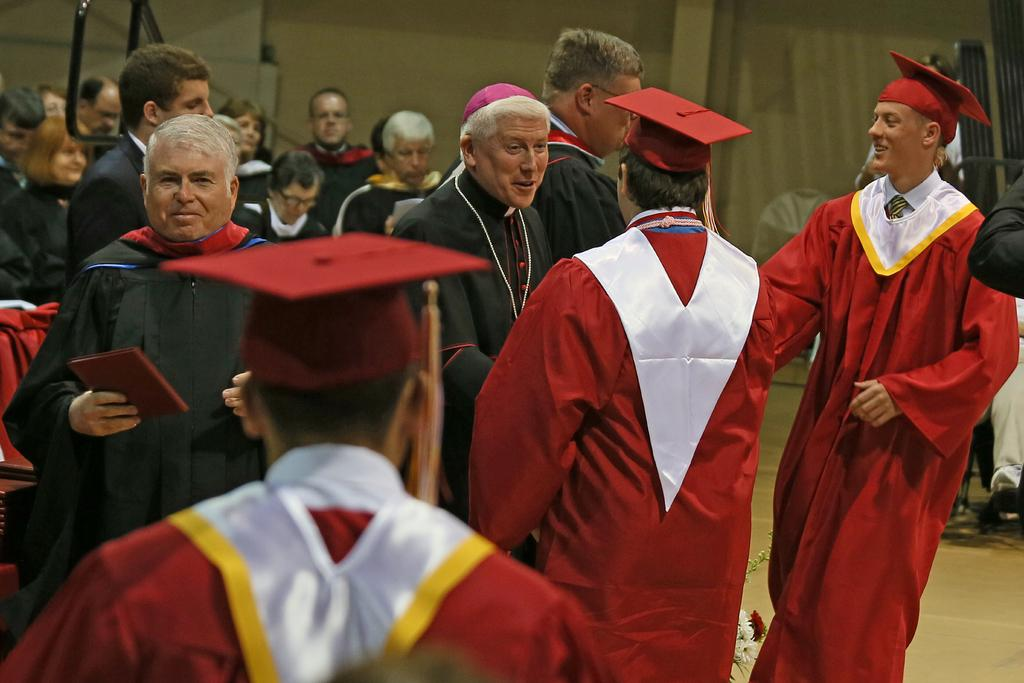Who is present in the image? There are people in the image. What are some of the people wearing? Some people are wearing academic dresses. What else can be seen in the image besides the people? There are objects in the image. What is visible in the background of the image? There is a wall in the background of the image. How many servants are present in the image? There is no mention of servants in the image, so it is impossible to determine their presence or number. What type of hen can be seen in the image? There is no hen present in the image. 